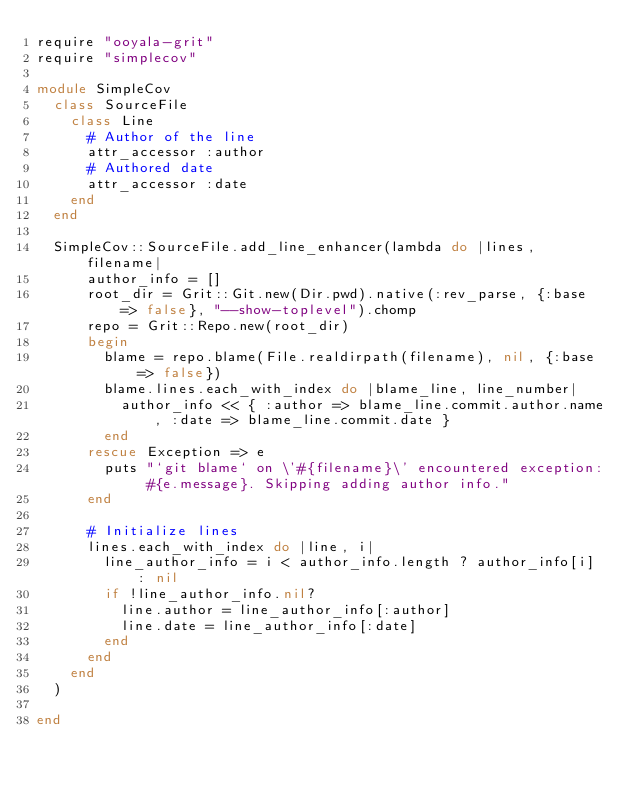Convert code to text. <code><loc_0><loc_0><loc_500><loc_500><_Ruby_>require "ooyala-grit"
require "simplecov"

module SimpleCov
  class SourceFile
    class Line
      # Author of the line
      attr_accessor :author
      # Authored date
      attr_accessor :date
    end
  end

  SimpleCov::SourceFile.add_line_enhancer(lambda do |lines, filename|
      author_info = []
      root_dir = Grit::Git.new(Dir.pwd).native(:rev_parse, {:base => false}, "--show-toplevel").chomp
      repo = Grit::Repo.new(root_dir)
      begin
        blame = repo.blame(File.realdirpath(filename), nil, {:base => false})
        blame.lines.each_with_index do |blame_line, line_number|
          author_info << { :author => blame_line.commit.author.name, :date => blame_line.commit.date }
        end
      rescue Exception => e
        puts "`git blame` on \'#{filename}\' encountered exception: #{e.message}. Skipping adding author info."
      end

      # Initialize lines
      lines.each_with_index do |line, i|
        line_author_info = i < author_info.length ? author_info[i] : nil
        if !line_author_info.nil?
          line.author = line_author_info[:author]
          line.date = line_author_info[:date]
        end
      end
    end
  )

end

</code> 